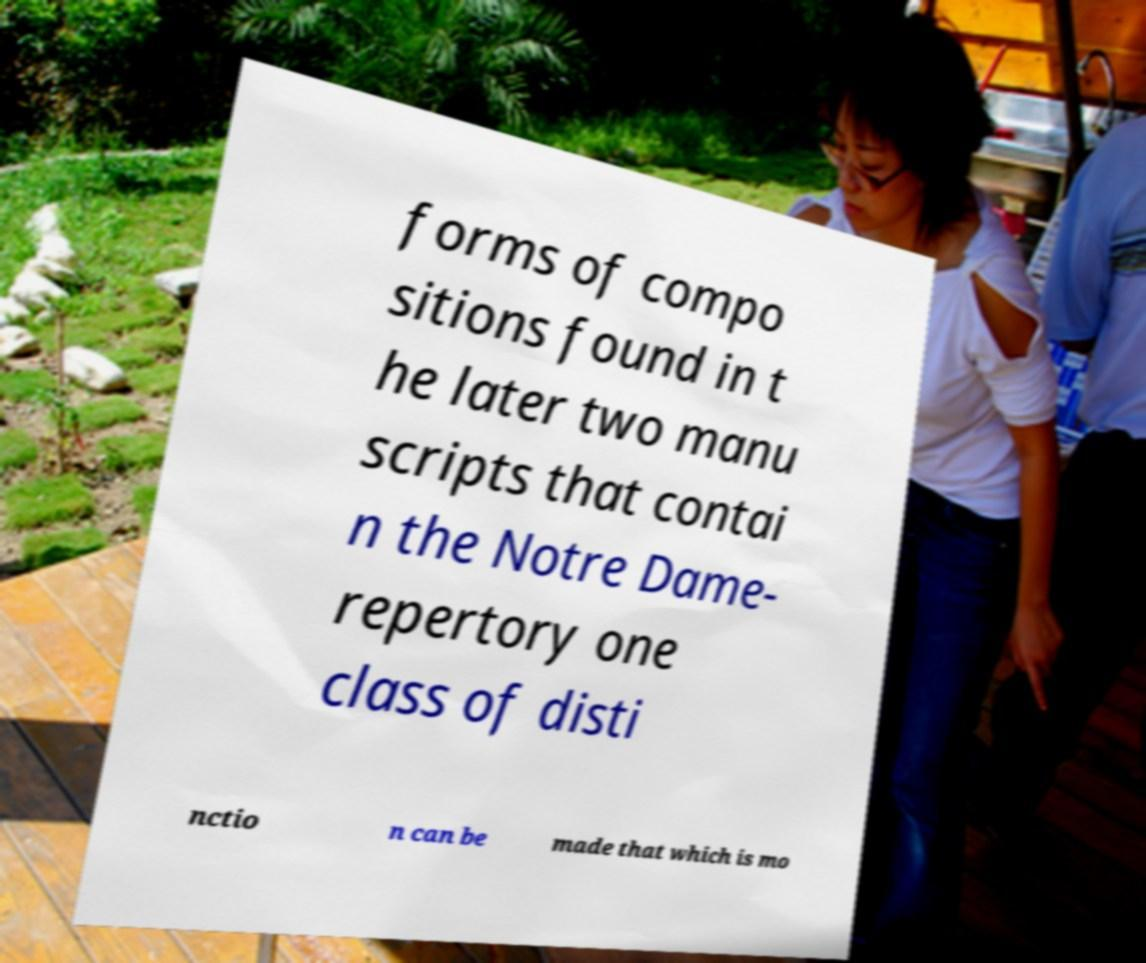Could you extract and type out the text from this image? forms of compo sitions found in t he later two manu scripts that contai n the Notre Dame- repertory one class of disti nctio n can be made that which is mo 